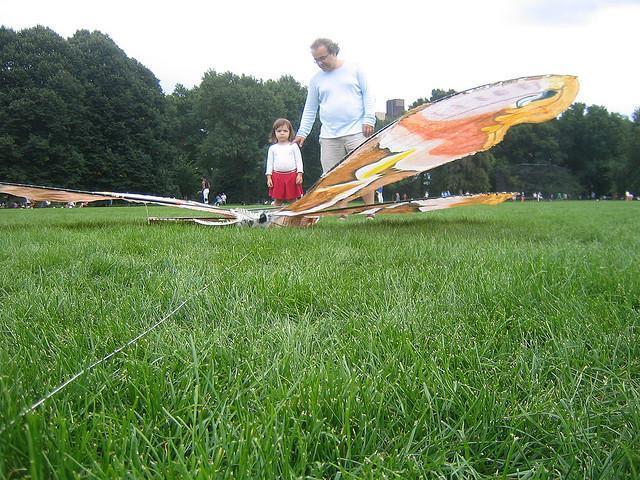How many people are in the photo?
Give a very brief answer. 2. 